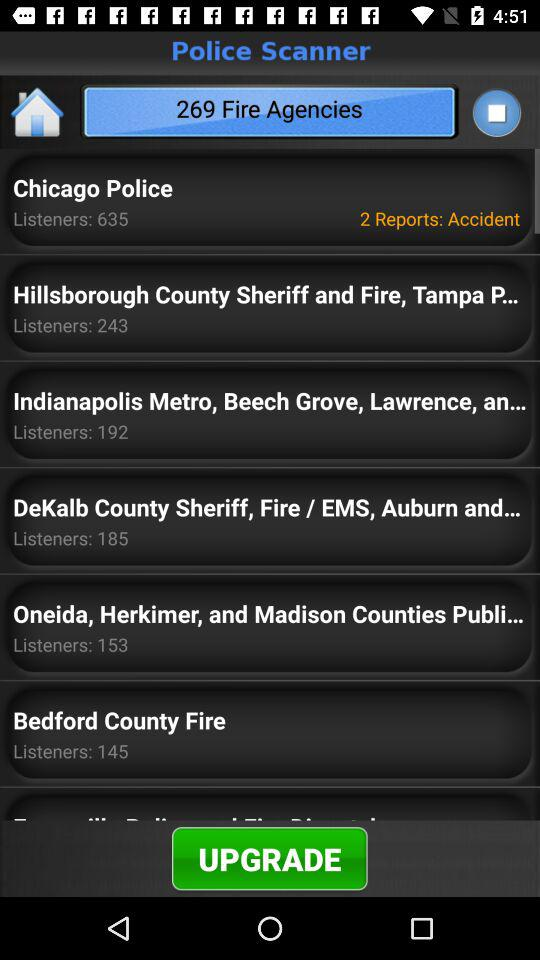How many accidents are reported to "Chicago Police"? Chicago police reported 2 accidents. 